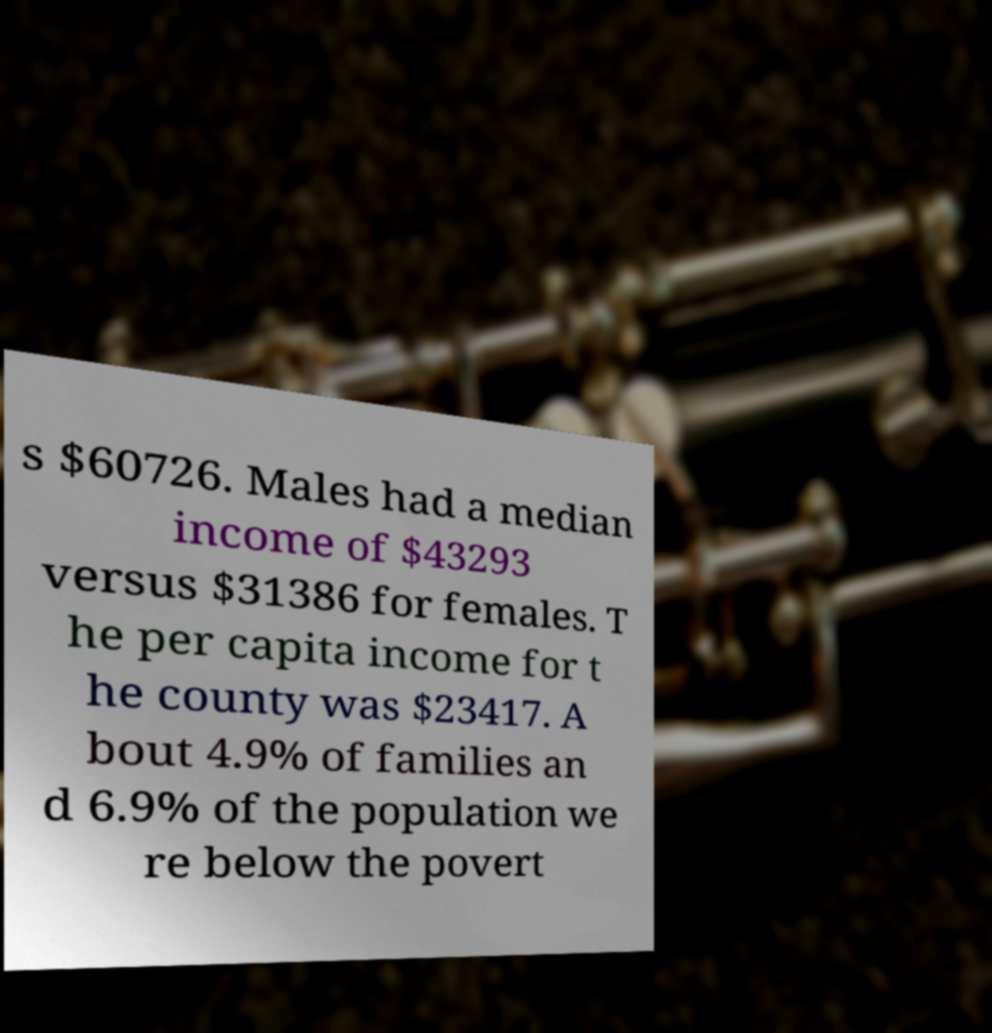Could you extract and type out the text from this image? s $60726. Males had a median income of $43293 versus $31386 for females. T he per capita income for t he county was $23417. A bout 4.9% of families an d 6.9% of the population we re below the povert 